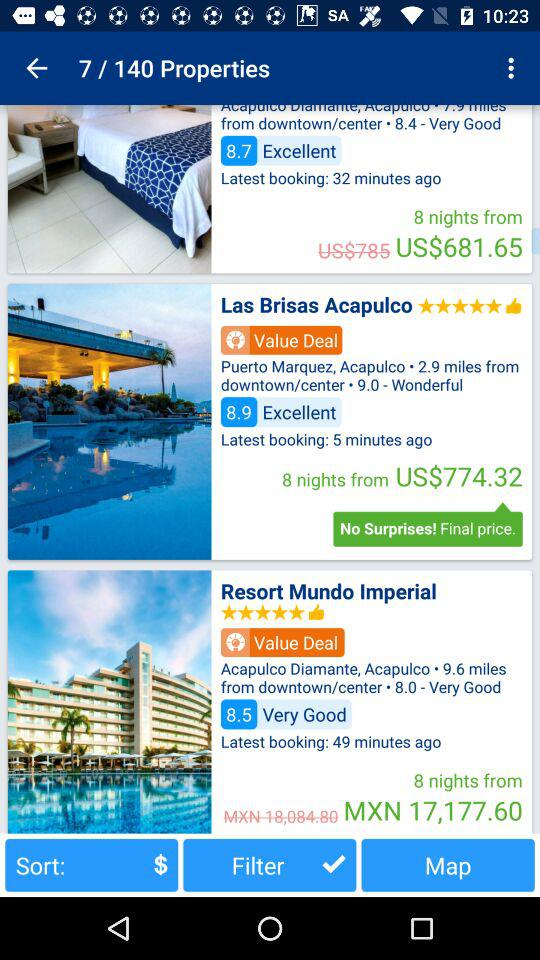How many properties in total are there? There are 140 properties. 